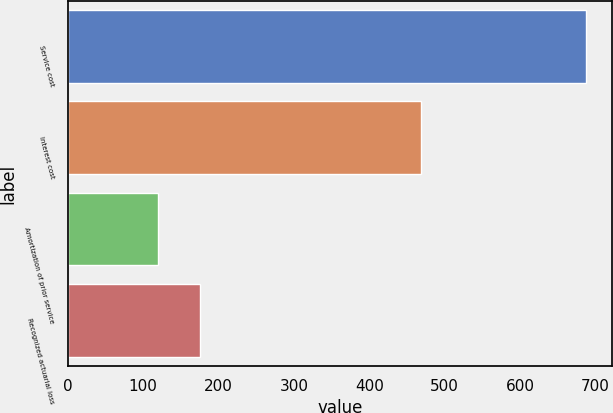Convert chart. <chart><loc_0><loc_0><loc_500><loc_500><bar_chart><fcel>Service cost<fcel>Interest cost<fcel>Amortization of prior service<fcel>Recognized actuarial loss<nl><fcel>688<fcel>468<fcel>119<fcel>175.9<nl></chart> 